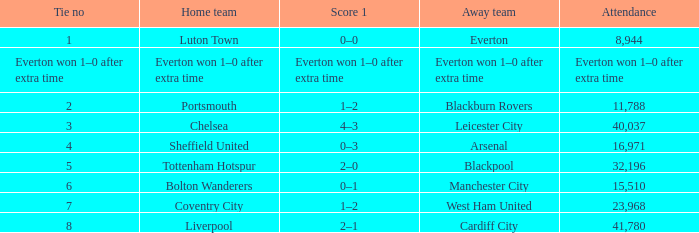For which home team was the attendance record 16,971? Sheffield United. 